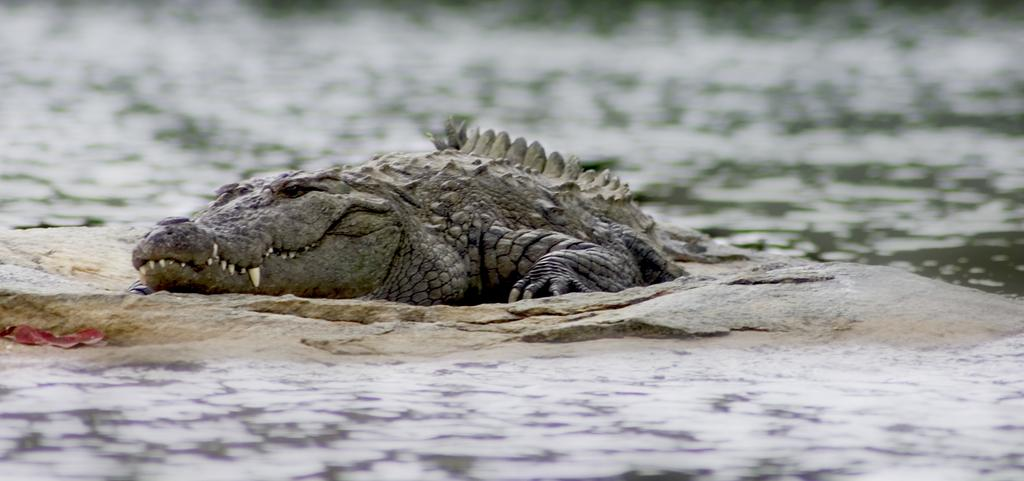What type of surface can be seen in the image? There is ground visible in the image. What kind of living creature is present in the image? There is an animal in the image. Can you describe the color of the animal? The animal is brown and black in color. What can be seen in the distance in the image? There is water visible in the background of the image. What type of tin can be seen in the image? There is no tin present in the image. How does the sail affect the movement of the animal in the image? There is no sail present in the image, and the animal's movement is not affected by any sail. 